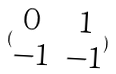<formula> <loc_0><loc_0><loc_500><loc_500>( \begin{matrix} 0 & 1 \\ - 1 & - 1 \end{matrix} )</formula> 